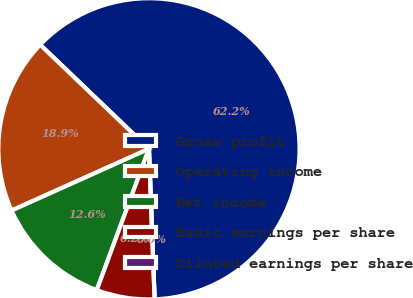Convert chart. <chart><loc_0><loc_0><loc_500><loc_500><pie_chart><fcel>Gross profit<fcel>Operating income<fcel>Net income<fcel>Basic earnings per share<fcel>Diluted earnings per share<nl><fcel>62.25%<fcel>18.87%<fcel>12.65%<fcel>6.23%<fcel>0.0%<nl></chart> 